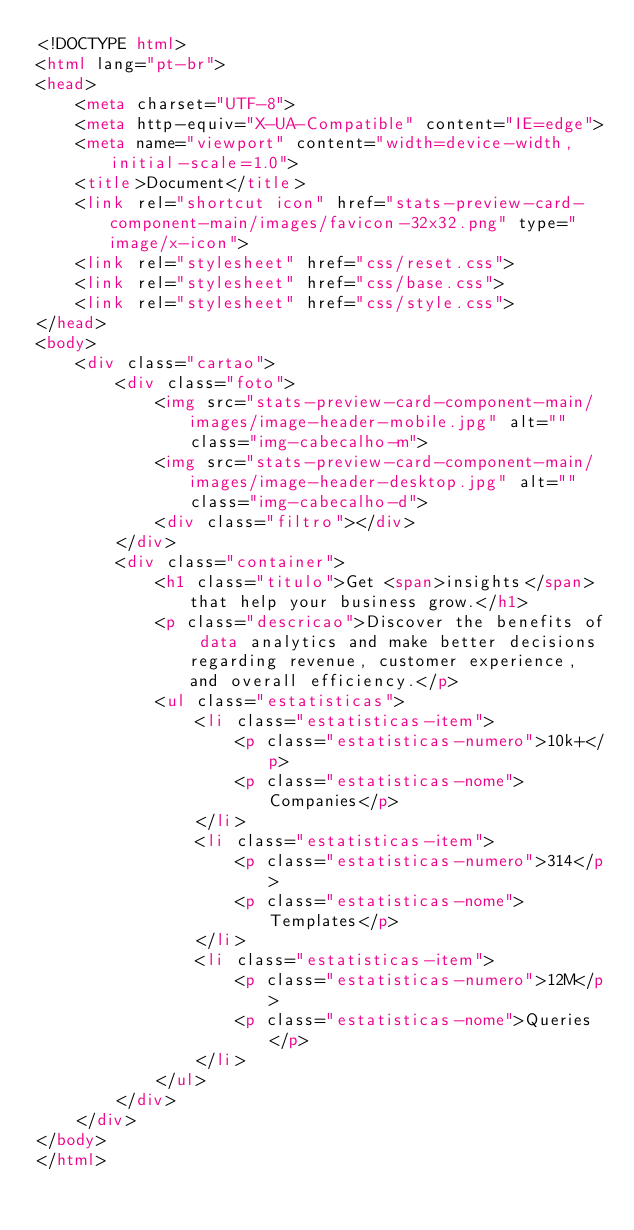<code> <loc_0><loc_0><loc_500><loc_500><_HTML_><!DOCTYPE html>
<html lang="pt-br">
<head>
    <meta charset="UTF-8">
    <meta http-equiv="X-UA-Compatible" content="IE=edge">
    <meta name="viewport" content="width=device-width, initial-scale=1.0">
    <title>Document</title>
    <link rel="shortcut icon" href="stats-preview-card-component-main/images/favicon-32x32.png" type="image/x-icon">
    <link rel="stylesheet" href="css/reset.css">
    <link rel="stylesheet" href="css/base.css">
    <link rel="stylesheet" href="css/style.css">
</head>
<body>
    <div class="cartao">
        <div class="foto">
            <img src="stats-preview-card-component-main/images/image-header-mobile.jpg" alt="" class="img-cabecalho-m">
            <img src="stats-preview-card-component-main/images/image-header-desktop.jpg" alt="" class="img-cabecalho-d">
            <div class="filtro"></div>
        </div>
        <div class="container">
            <h1 class="titulo">Get <span>insights</span> that help your business grow.</h1>
            <p class="descricao">Discover the benefits of data analytics and make better decisions regarding revenue, customer experience, and overall efficiency.</p>
            <ul class="estatisticas">
                <li class="estatisticas-item">
                    <p class="estatisticas-numero">10k+</p>
                    <p class="estatisticas-nome">Companies</p>
                </li>
                <li class="estatisticas-item">
                    <p class="estatisticas-numero">314</p>
                    <p class="estatisticas-nome">Templates</p>
                </li>
                <li class="estatisticas-item">
                    <p class="estatisticas-numero">12M</p>
                    <p class="estatisticas-nome">Queries</p>
                </li>
            </ul>
        </div>
    </div>
</body>
</html></code> 